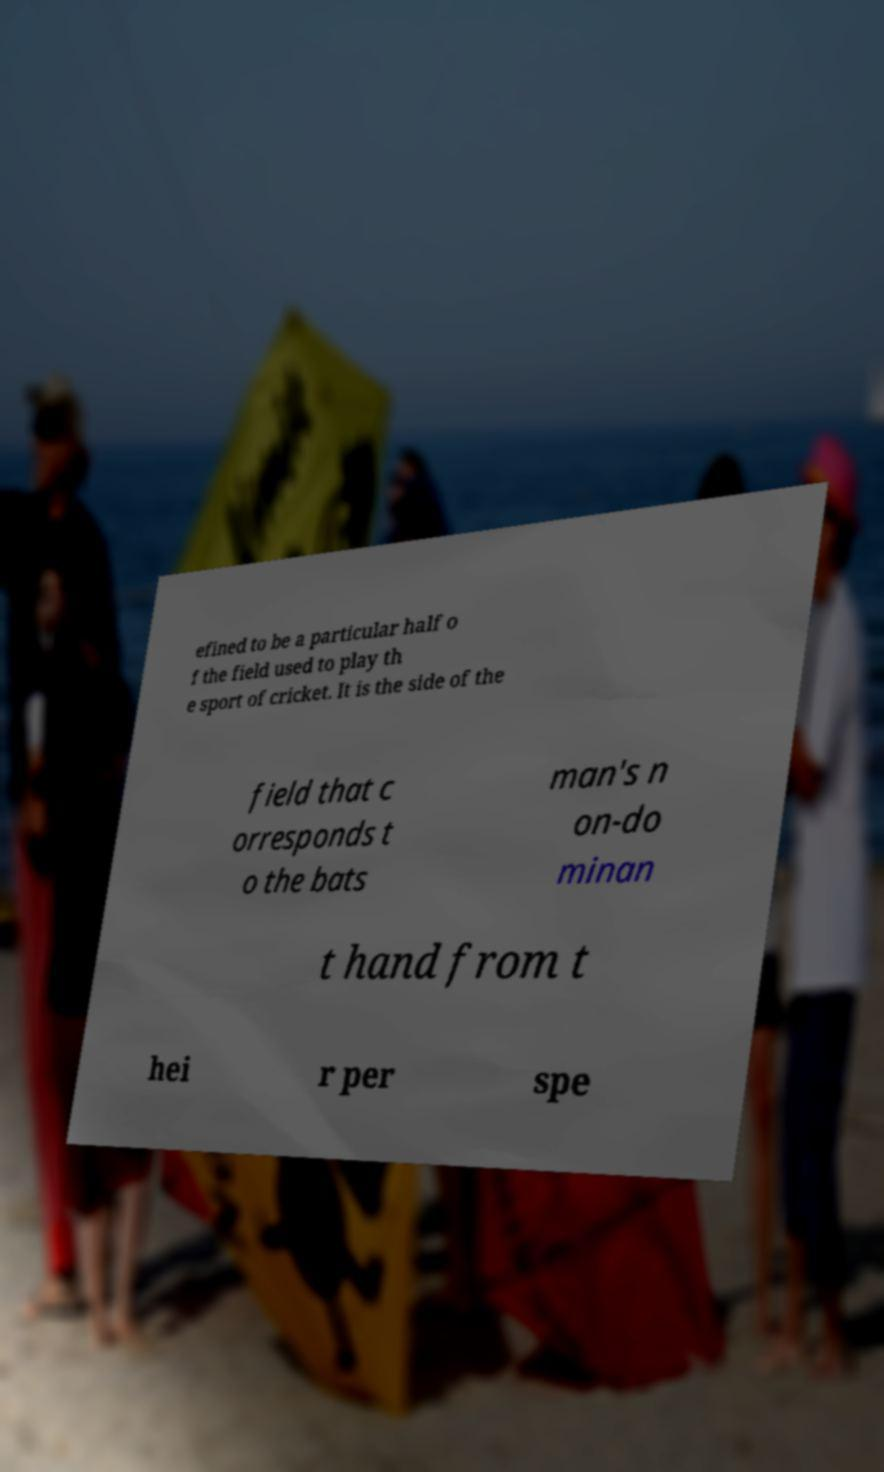For documentation purposes, I need the text within this image transcribed. Could you provide that? efined to be a particular half o f the field used to play th e sport of cricket. It is the side of the field that c orresponds t o the bats man's n on-do minan t hand from t hei r per spe 